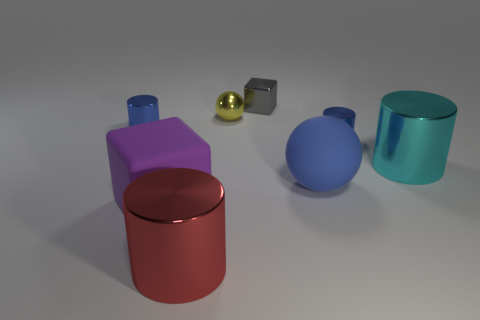Is the number of yellow shiny things behind the metal cube less than the number of small green blocks?
Give a very brief answer. No. What number of other matte things are the same size as the blue rubber thing?
Offer a very short reply. 1. The large metal thing on the left side of the small blue cylinder that is right of the metal thing that is to the left of the purple cube is what shape?
Keep it short and to the point. Cylinder. The metal cylinder on the left side of the big red cylinder is what color?
Offer a very short reply. Blue. What number of objects are large metallic cylinders on the right side of the metal block or tiny blue metal objects right of the big rubber cube?
Keep it short and to the point. 2. What number of other red metallic things are the same shape as the large red object?
Offer a very short reply. 0. There is a sphere that is the same size as the gray shiny thing; what color is it?
Offer a terse response. Yellow. What color is the big shiny thing that is behind the metallic cylinder in front of the big matte thing that is to the left of the small metal sphere?
Make the answer very short. Cyan. Do the yellow shiny thing and the matte thing that is left of the red object have the same size?
Keep it short and to the point. No. What number of objects are purple cubes or tiny shiny cylinders?
Offer a very short reply. 3. 